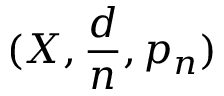Convert formula to latex. <formula><loc_0><loc_0><loc_500><loc_500>( X , { \frac { d } { n } } , p _ { n } )</formula> 